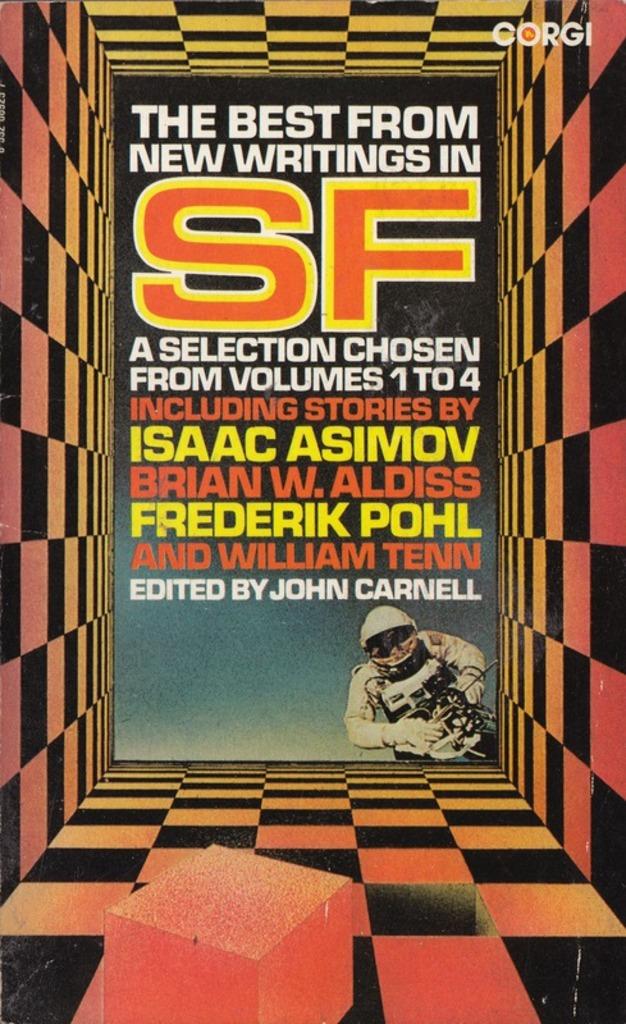Who edited the book?
Your answer should be very brief. John carnell. 